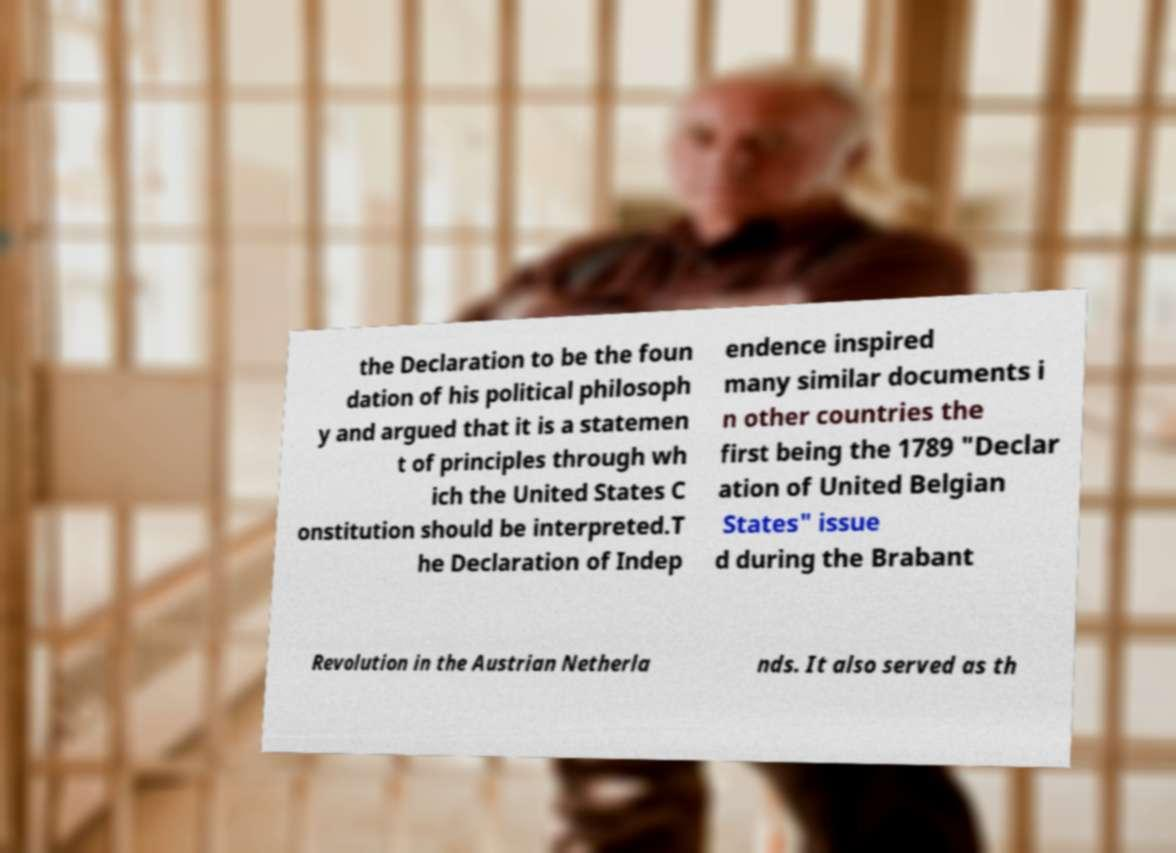For documentation purposes, I need the text within this image transcribed. Could you provide that? the Declaration to be the foun dation of his political philosoph y and argued that it is a statemen t of principles through wh ich the United States C onstitution should be interpreted.T he Declaration of Indep endence inspired many similar documents i n other countries the first being the 1789 "Declar ation of United Belgian States" issue d during the Brabant Revolution in the Austrian Netherla nds. It also served as th 